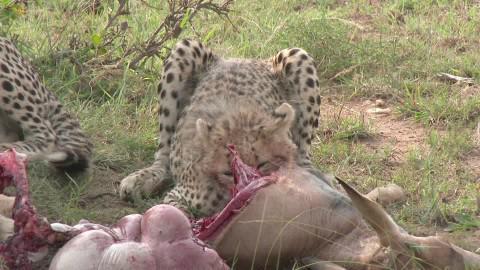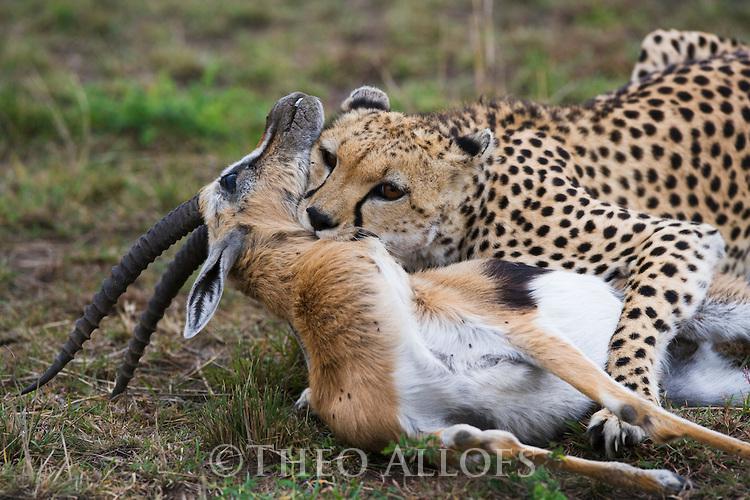The first image is the image on the left, the second image is the image on the right. Assess this claim about the two images: "The right image shows one cheetah capturing a gazelle-type animal, and the left image shows a cheetah crouched behind entrails.". Correct or not? Answer yes or no. Yes. The first image is the image on the left, the second image is the image on the right. Considering the images on both sides, is "A horned animal is being bitten on the ground by at least one cheetah in the image on the right." valid? Answer yes or no. Yes. 